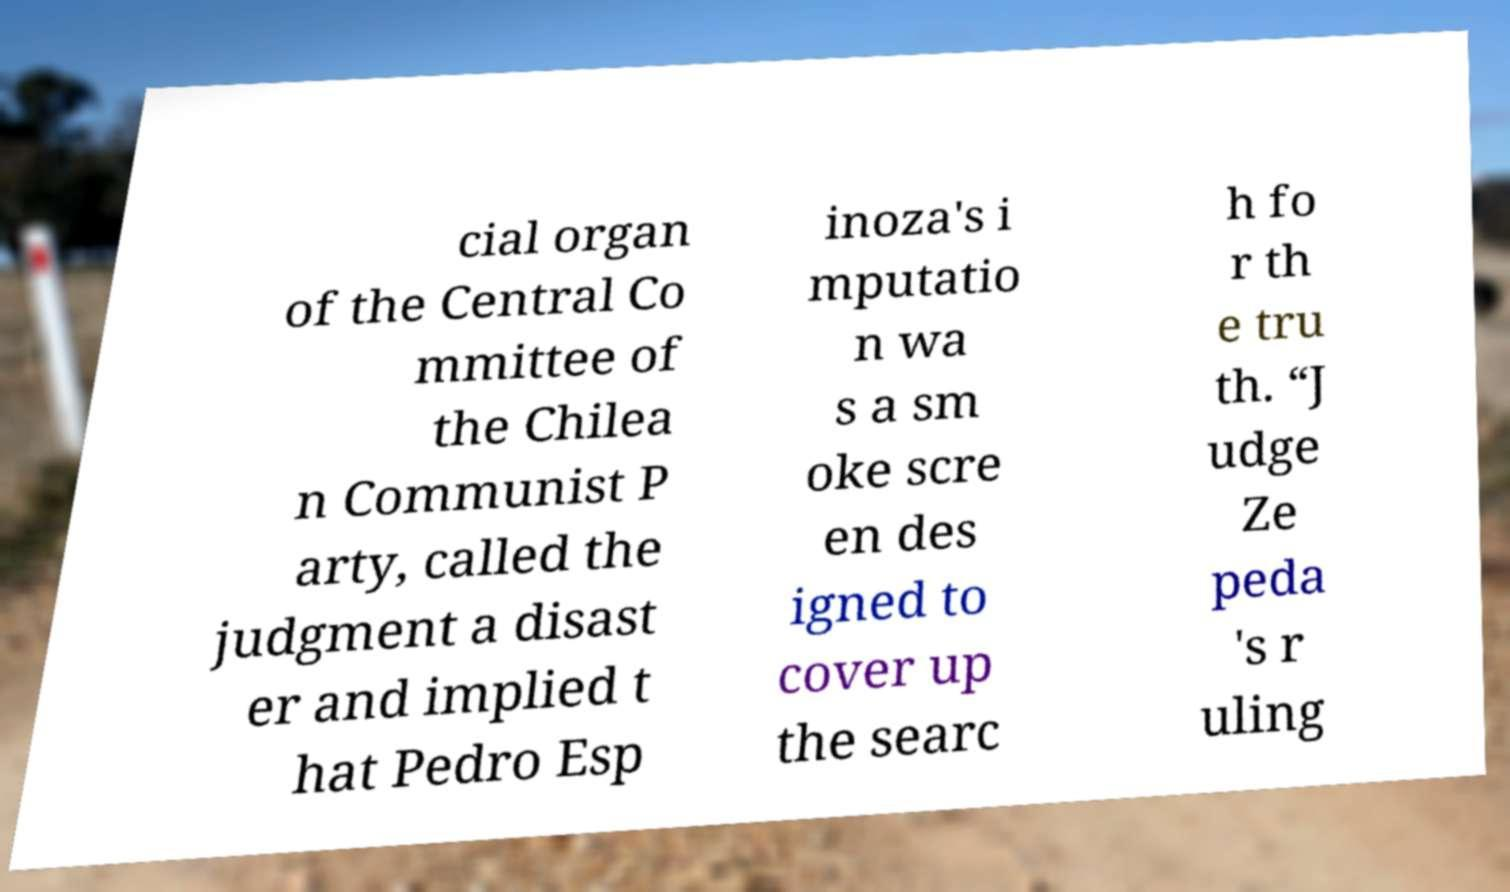Please identify and transcribe the text found in this image. cial organ of the Central Co mmittee of the Chilea n Communist P arty, called the judgment a disast er and implied t hat Pedro Esp inoza's i mputatio n wa s a sm oke scre en des igned to cover up the searc h fo r th e tru th. “J udge Ze peda 's r uling 